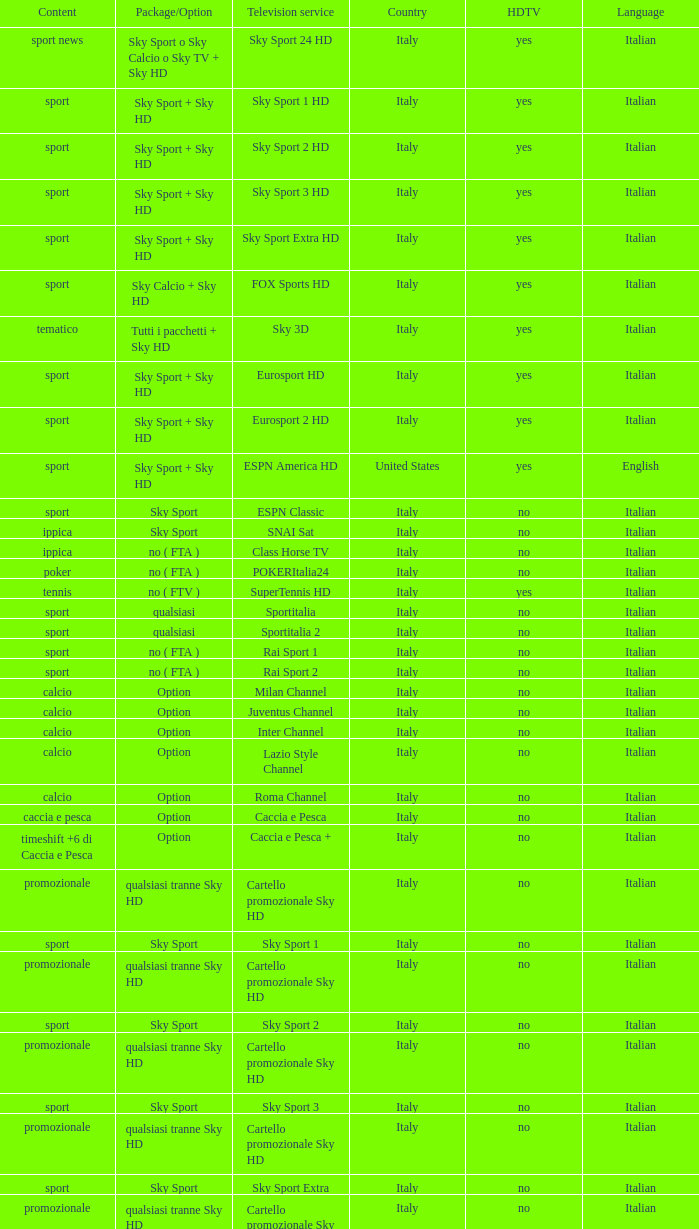What is Package/Option, when Content is Tennis? No ( ftv ). 